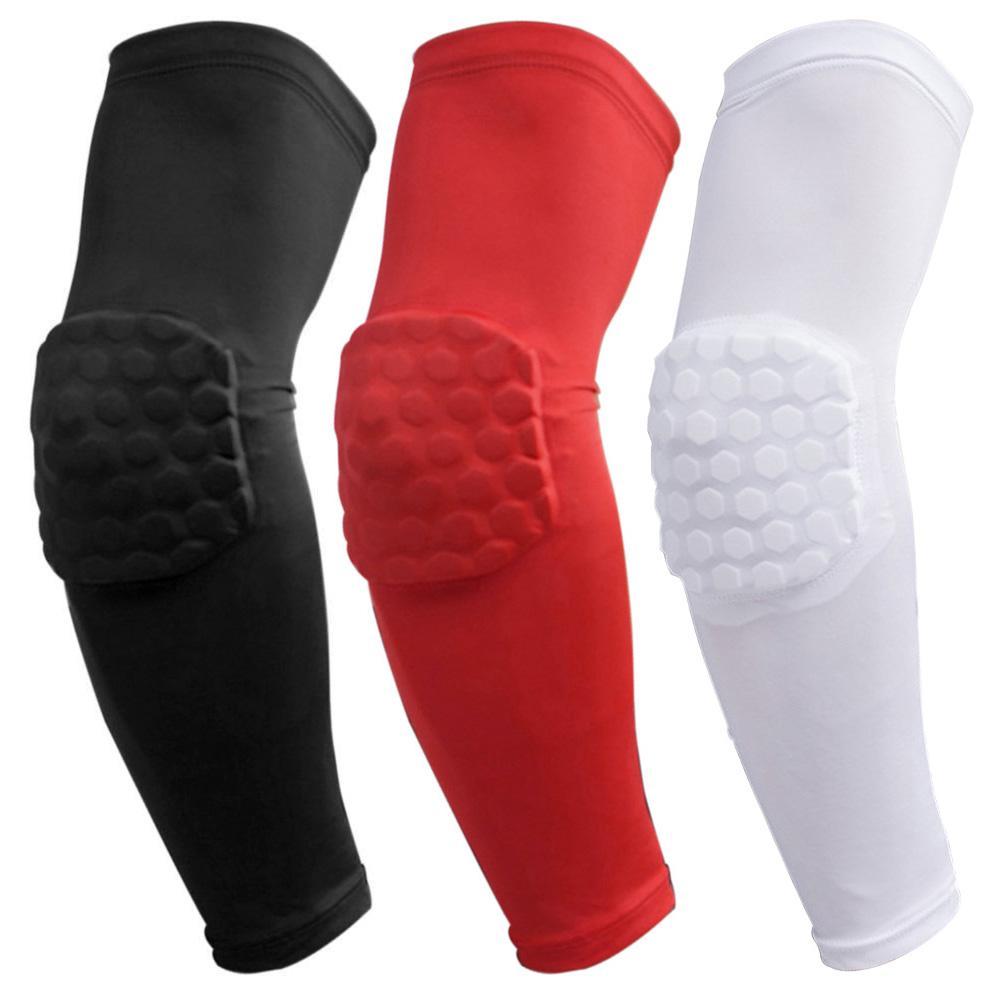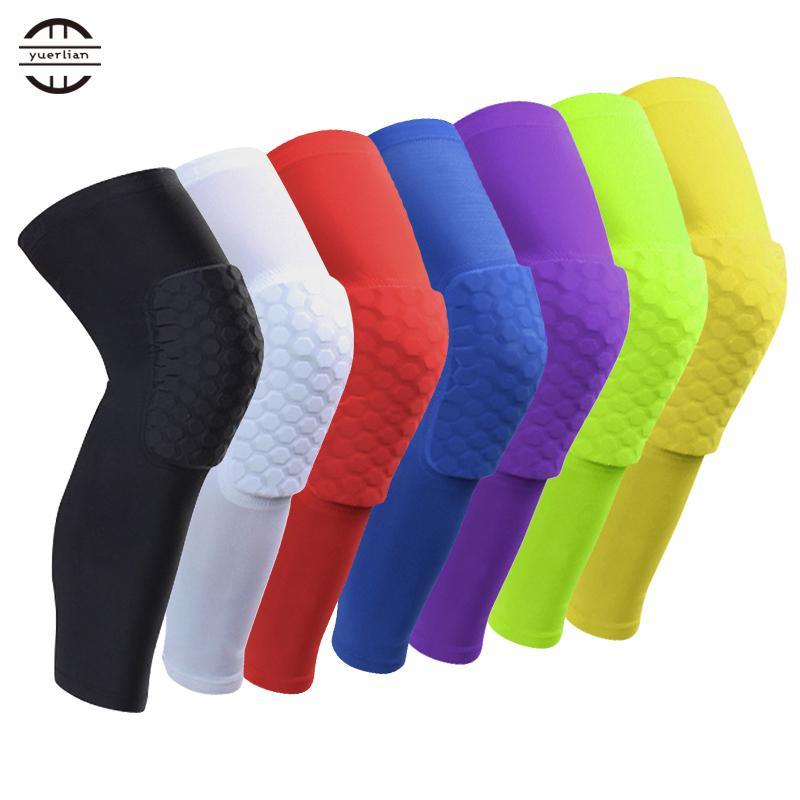The first image is the image on the left, the second image is the image on the right. Given the left and right images, does the statement "There is a white knee pad next to a red knee pad" hold true? Answer yes or no. Yes. The first image is the image on the left, the second image is the image on the right. Evaluate the accuracy of this statement regarding the images: "One of the images shows exactly one knee pad.". Is it true? Answer yes or no. No. 